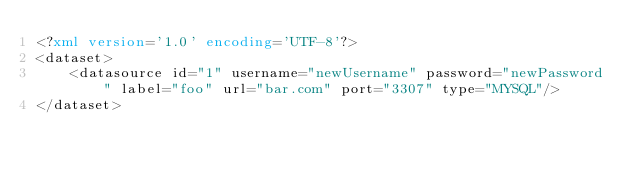Convert code to text. <code><loc_0><loc_0><loc_500><loc_500><_XML_><?xml version='1.0' encoding='UTF-8'?>
<dataset>
    <datasource id="1" username="newUsername" password="newPassword" label="foo" url="bar.com" port="3307" type="MYSQL"/>
</dataset></code> 